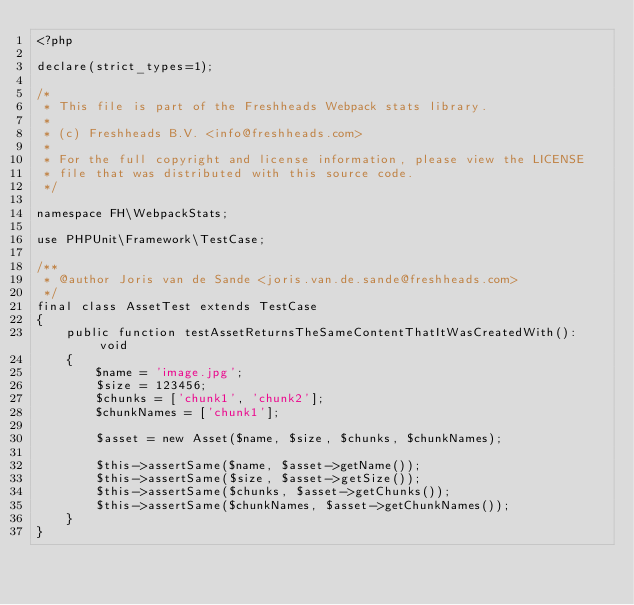Convert code to text. <code><loc_0><loc_0><loc_500><loc_500><_PHP_><?php

declare(strict_types=1);

/*
 * This file is part of the Freshheads Webpack stats library.
 *
 * (c) Freshheads B.V. <info@freshheads.com>
 *
 * For the full copyright and license information, please view the LICENSE
 * file that was distributed with this source code.
 */

namespace FH\WebpackStats;

use PHPUnit\Framework\TestCase;

/**
 * @author Joris van de Sande <joris.van.de.sande@freshheads.com>
 */
final class AssetTest extends TestCase
{
    public function testAssetReturnsTheSameContentThatItWasCreatedWith(): void
    {
        $name = 'image.jpg';
        $size = 123456;
        $chunks = ['chunk1', 'chunk2'];
        $chunkNames = ['chunk1'];

        $asset = new Asset($name, $size, $chunks, $chunkNames);

        $this->assertSame($name, $asset->getName());
        $this->assertSame($size, $asset->getSize());
        $this->assertSame($chunks, $asset->getChunks());
        $this->assertSame($chunkNames, $asset->getChunkNames());
    }
}
</code> 